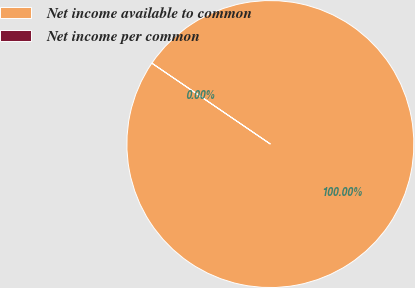Convert chart. <chart><loc_0><loc_0><loc_500><loc_500><pie_chart><fcel>Net income available to common<fcel>Net income per common<nl><fcel>100.0%<fcel>0.0%<nl></chart> 